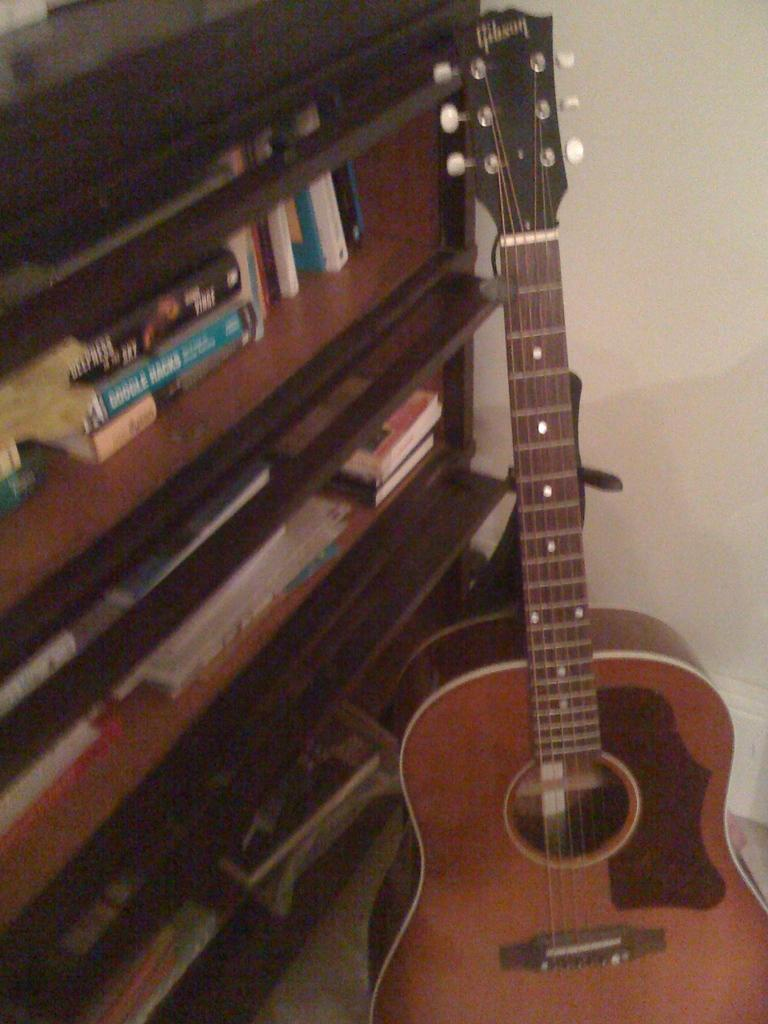What musical instrument is present in the image? There is a guitar in the image. What else can be found in the image besides the guitar? There is a cupboard with books inside in the image. What is visible in the background of the image? There is a wall in the background of the image. How many pairs of shoes are visible in the image? There are no shoes present in the image. What type of field can be seen in the background of the image? There is no field visible in the image; it only shows a wall in the background. 